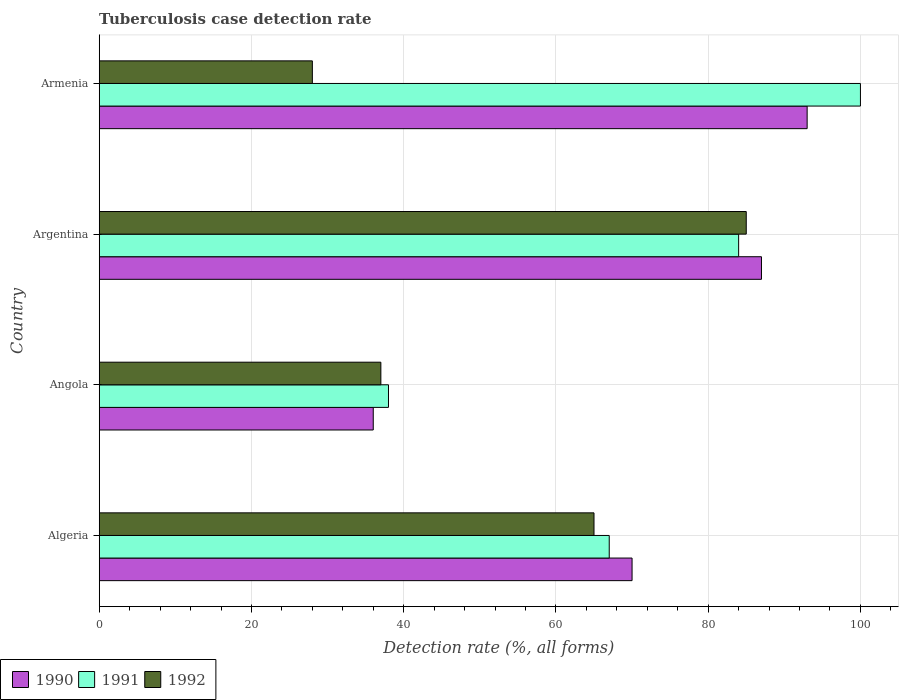How many different coloured bars are there?
Your answer should be compact. 3. Are the number of bars per tick equal to the number of legend labels?
Your response must be concise. Yes. Are the number of bars on each tick of the Y-axis equal?
Ensure brevity in your answer.  Yes. How many bars are there on the 4th tick from the top?
Ensure brevity in your answer.  3. What is the label of the 1st group of bars from the top?
Offer a terse response. Armenia. Across all countries, what is the maximum tuberculosis case detection rate in in 1990?
Make the answer very short. 93. In which country was the tuberculosis case detection rate in in 1991 maximum?
Your answer should be compact. Armenia. In which country was the tuberculosis case detection rate in in 1990 minimum?
Give a very brief answer. Angola. What is the total tuberculosis case detection rate in in 1991 in the graph?
Your answer should be very brief. 289. What is the difference between the tuberculosis case detection rate in in 1991 in Algeria and the tuberculosis case detection rate in in 1992 in Armenia?
Your answer should be very brief. 39. What is the average tuberculosis case detection rate in in 1990 per country?
Your answer should be very brief. 71.5. What is the difference between the tuberculosis case detection rate in in 1990 and tuberculosis case detection rate in in 1991 in Angola?
Offer a terse response. -2. In how many countries, is the tuberculosis case detection rate in in 1992 greater than 64 %?
Provide a short and direct response. 2. What is the ratio of the tuberculosis case detection rate in in 1990 in Angola to that in Armenia?
Provide a short and direct response. 0.39. Is the tuberculosis case detection rate in in 1991 in Algeria less than that in Armenia?
Ensure brevity in your answer.  Yes. What is the difference between the highest and the lowest tuberculosis case detection rate in in 1990?
Offer a very short reply. 57. What does the 2nd bar from the top in Argentina represents?
Give a very brief answer. 1991. What does the 2nd bar from the bottom in Armenia represents?
Your answer should be compact. 1991. How many bars are there?
Provide a short and direct response. 12. How many countries are there in the graph?
Keep it short and to the point. 4. Are the values on the major ticks of X-axis written in scientific E-notation?
Make the answer very short. No. Does the graph contain any zero values?
Give a very brief answer. No. Does the graph contain grids?
Your answer should be compact. Yes. How are the legend labels stacked?
Make the answer very short. Horizontal. What is the title of the graph?
Offer a terse response. Tuberculosis case detection rate. Does "2011" appear as one of the legend labels in the graph?
Your response must be concise. No. What is the label or title of the X-axis?
Your response must be concise. Detection rate (%, all forms). What is the Detection rate (%, all forms) in 1990 in Algeria?
Your answer should be compact. 70. What is the Detection rate (%, all forms) of 1992 in Algeria?
Make the answer very short. 65. What is the Detection rate (%, all forms) of 1991 in Angola?
Your answer should be compact. 38. What is the Detection rate (%, all forms) in 1992 in Angola?
Keep it short and to the point. 37. What is the Detection rate (%, all forms) in 1990 in Armenia?
Give a very brief answer. 93. What is the Detection rate (%, all forms) of 1991 in Armenia?
Your answer should be compact. 100. Across all countries, what is the maximum Detection rate (%, all forms) in 1990?
Your response must be concise. 93. Across all countries, what is the minimum Detection rate (%, all forms) of 1991?
Ensure brevity in your answer.  38. What is the total Detection rate (%, all forms) in 1990 in the graph?
Offer a terse response. 286. What is the total Detection rate (%, all forms) of 1991 in the graph?
Offer a terse response. 289. What is the total Detection rate (%, all forms) in 1992 in the graph?
Ensure brevity in your answer.  215. What is the difference between the Detection rate (%, all forms) in 1990 in Algeria and that in Angola?
Offer a very short reply. 34. What is the difference between the Detection rate (%, all forms) of 1990 in Algeria and that in Armenia?
Keep it short and to the point. -23. What is the difference between the Detection rate (%, all forms) of 1991 in Algeria and that in Armenia?
Provide a succinct answer. -33. What is the difference between the Detection rate (%, all forms) of 1992 in Algeria and that in Armenia?
Make the answer very short. 37. What is the difference between the Detection rate (%, all forms) of 1990 in Angola and that in Argentina?
Ensure brevity in your answer.  -51. What is the difference between the Detection rate (%, all forms) of 1991 in Angola and that in Argentina?
Offer a very short reply. -46. What is the difference between the Detection rate (%, all forms) of 1992 in Angola and that in Argentina?
Give a very brief answer. -48. What is the difference between the Detection rate (%, all forms) of 1990 in Angola and that in Armenia?
Your answer should be compact. -57. What is the difference between the Detection rate (%, all forms) in 1991 in Angola and that in Armenia?
Offer a terse response. -62. What is the difference between the Detection rate (%, all forms) of 1992 in Angola and that in Armenia?
Give a very brief answer. 9. What is the difference between the Detection rate (%, all forms) of 1991 in Argentina and that in Armenia?
Make the answer very short. -16. What is the difference between the Detection rate (%, all forms) of 1990 in Algeria and the Detection rate (%, all forms) of 1991 in Angola?
Ensure brevity in your answer.  32. What is the difference between the Detection rate (%, all forms) of 1990 in Algeria and the Detection rate (%, all forms) of 1991 in Argentina?
Give a very brief answer. -14. What is the difference between the Detection rate (%, all forms) in 1990 in Algeria and the Detection rate (%, all forms) in 1992 in Argentina?
Your answer should be very brief. -15. What is the difference between the Detection rate (%, all forms) of 1991 in Algeria and the Detection rate (%, all forms) of 1992 in Argentina?
Provide a succinct answer. -18. What is the difference between the Detection rate (%, all forms) in 1990 in Algeria and the Detection rate (%, all forms) in 1991 in Armenia?
Offer a very short reply. -30. What is the difference between the Detection rate (%, all forms) in 1990 in Angola and the Detection rate (%, all forms) in 1991 in Argentina?
Your response must be concise. -48. What is the difference between the Detection rate (%, all forms) of 1990 in Angola and the Detection rate (%, all forms) of 1992 in Argentina?
Ensure brevity in your answer.  -49. What is the difference between the Detection rate (%, all forms) in 1991 in Angola and the Detection rate (%, all forms) in 1992 in Argentina?
Provide a succinct answer. -47. What is the difference between the Detection rate (%, all forms) of 1990 in Angola and the Detection rate (%, all forms) of 1991 in Armenia?
Your answer should be very brief. -64. What is the difference between the Detection rate (%, all forms) of 1990 in Angola and the Detection rate (%, all forms) of 1992 in Armenia?
Ensure brevity in your answer.  8. What is the difference between the Detection rate (%, all forms) of 1990 in Argentina and the Detection rate (%, all forms) of 1992 in Armenia?
Your response must be concise. 59. What is the average Detection rate (%, all forms) of 1990 per country?
Make the answer very short. 71.5. What is the average Detection rate (%, all forms) of 1991 per country?
Provide a succinct answer. 72.25. What is the average Detection rate (%, all forms) of 1992 per country?
Provide a succinct answer. 53.75. What is the difference between the Detection rate (%, all forms) of 1991 and Detection rate (%, all forms) of 1992 in Algeria?
Offer a very short reply. 2. What is the difference between the Detection rate (%, all forms) of 1990 and Detection rate (%, all forms) of 1991 in Angola?
Ensure brevity in your answer.  -2. What is the difference between the Detection rate (%, all forms) of 1990 and Detection rate (%, all forms) of 1992 in Angola?
Make the answer very short. -1. What is the difference between the Detection rate (%, all forms) in 1990 and Detection rate (%, all forms) in 1991 in Argentina?
Offer a terse response. 3. What is the difference between the Detection rate (%, all forms) of 1990 and Detection rate (%, all forms) of 1992 in Argentina?
Give a very brief answer. 2. What is the difference between the Detection rate (%, all forms) in 1990 and Detection rate (%, all forms) in 1992 in Armenia?
Provide a short and direct response. 65. What is the ratio of the Detection rate (%, all forms) of 1990 in Algeria to that in Angola?
Give a very brief answer. 1.94. What is the ratio of the Detection rate (%, all forms) in 1991 in Algeria to that in Angola?
Offer a very short reply. 1.76. What is the ratio of the Detection rate (%, all forms) of 1992 in Algeria to that in Angola?
Ensure brevity in your answer.  1.76. What is the ratio of the Detection rate (%, all forms) in 1990 in Algeria to that in Argentina?
Keep it short and to the point. 0.8. What is the ratio of the Detection rate (%, all forms) in 1991 in Algeria to that in Argentina?
Provide a short and direct response. 0.8. What is the ratio of the Detection rate (%, all forms) of 1992 in Algeria to that in Argentina?
Your response must be concise. 0.76. What is the ratio of the Detection rate (%, all forms) in 1990 in Algeria to that in Armenia?
Offer a terse response. 0.75. What is the ratio of the Detection rate (%, all forms) in 1991 in Algeria to that in Armenia?
Offer a terse response. 0.67. What is the ratio of the Detection rate (%, all forms) in 1992 in Algeria to that in Armenia?
Provide a short and direct response. 2.32. What is the ratio of the Detection rate (%, all forms) of 1990 in Angola to that in Argentina?
Offer a terse response. 0.41. What is the ratio of the Detection rate (%, all forms) in 1991 in Angola to that in Argentina?
Offer a very short reply. 0.45. What is the ratio of the Detection rate (%, all forms) of 1992 in Angola to that in Argentina?
Keep it short and to the point. 0.44. What is the ratio of the Detection rate (%, all forms) of 1990 in Angola to that in Armenia?
Provide a short and direct response. 0.39. What is the ratio of the Detection rate (%, all forms) of 1991 in Angola to that in Armenia?
Give a very brief answer. 0.38. What is the ratio of the Detection rate (%, all forms) in 1992 in Angola to that in Armenia?
Ensure brevity in your answer.  1.32. What is the ratio of the Detection rate (%, all forms) in 1990 in Argentina to that in Armenia?
Offer a very short reply. 0.94. What is the ratio of the Detection rate (%, all forms) in 1991 in Argentina to that in Armenia?
Make the answer very short. 0.84. What is the ratio of the Detection rate (%, all forms) in 1992 in Argentina to that in Armenia?
Make the answer very short. 3.04. What is the difference between the highest and the second highest Detection rate (%, all forms) of 1990?
Give a very brief answer. 6. What is the difference between the highest and the second highest Detection rate (%, all forms) of 1991?
Your answer should be very brief. 16. What is the difference between the highest and the second highest Detection rate (%, all forms) in 1992?
Ensure brevity in your answer.  20. What is the difference between the highest and the lowest Detection rate (%, all forms) in 1990?
Provide a short and direct response. 57. What is the difference between the highest and the lowest Detection rate (%, all forms) in 1991?
Make the answer very short. 62. 